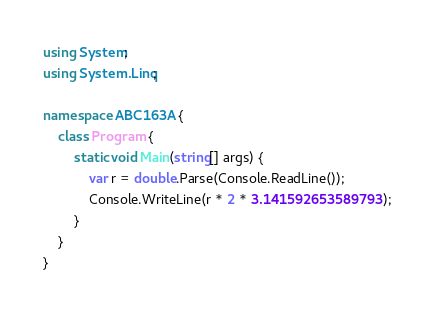<code> <loc_0><loc_0><loc_500><loc_500><_C#_>using System;
using System.Linq;

namespace ABC163A {
    class Program {
        static void Main(string[] args) {
            var r = double.Parse(Console.ReadLine());
            Console.WriteLine(r * 2 * 3.141592653589793);
        }
    }
}</code> 